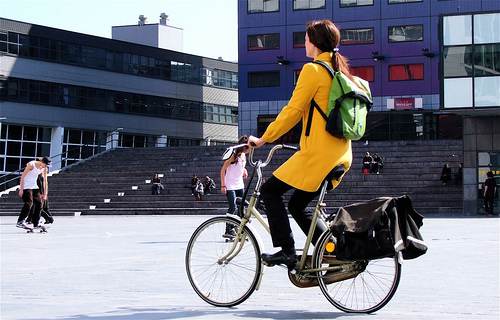<image>
Can you confirm if the lady is on the skateboard? No. The lady is not positioned on the skateboard. They may be near each other, but the lady is not supported by or resting on top of the skateboard. Is there a man on the cycle? No. The man is not positioned on the cycle. They may be near each other, but the man is not supported by or resting on top of the cycle. 